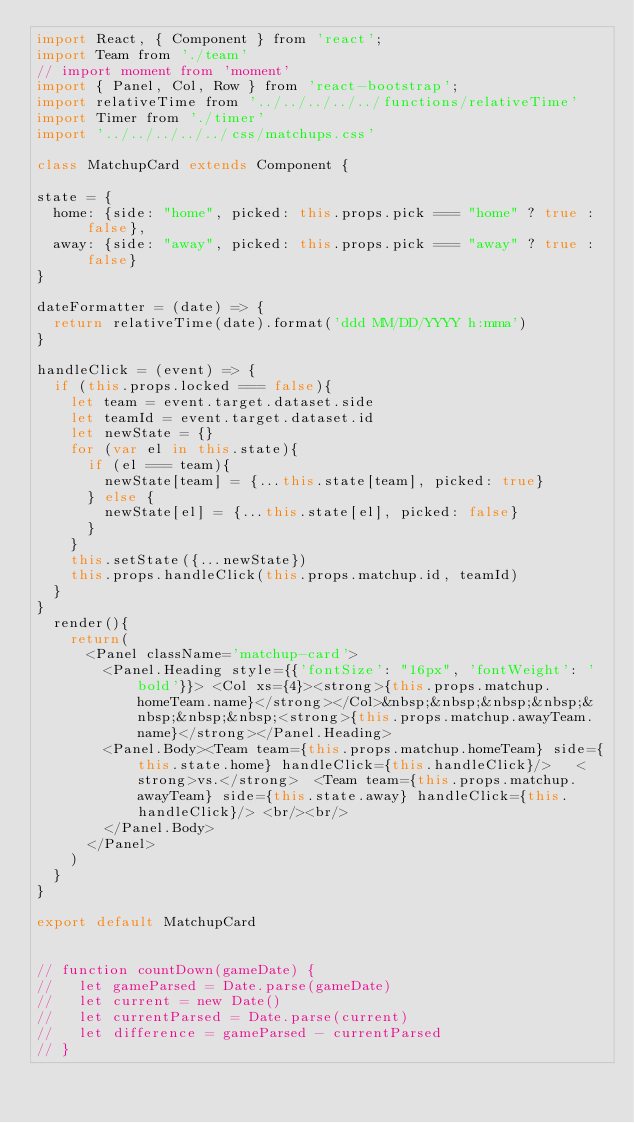<code> <loc_0><loc_0><loc_500><loc_500><_JavaScript_>import React, { Component } from 'react';
import Team from './team'
// import moment from 'moment'
import { Panel, Col, Row } from 'react-bootstrap';
import relativeTime from '../../../../../functions/relativeTime'
import Timer from './timer'
import '../../../../../css/matchups.css'

class MatchupCard extends Component {

state = {
  home: {side: "home", picked: this.props.pick === "home" ? true : false},
  away: {side: "away", picked: this.props.pick === "away" ? true : false}
}

dateFormatter = (date) => {
  return relativeTime(date).format('ddd MM/DD/YYYY h:mma')
}

handleClick = (event) => {
  if (this.props.locked === false){
    let team = event.target.dataset.side
    let teamId = event.target.dataset.id
    let newState = {}
    for (var el in this.state){
      if (el === team){
        newState[team] = {...this.state[team], picked: true}
      } else {
        newState[el] = {...this.state[el], picked: false}
      }
    }
    this.setState({...newState})
    this.props.handleClick(this.props.matchup.id, teamId)
  }
}
  render(){
    return(
      <Panel className='matchup-card'>
        <Panel.Heading style={{'fontSize': "16px", 'fontWeight': 'bold'}}> <Col xs={4}><strong>{this.props.matchup.homeTeam.name}</strong></Col>&nbsp;&nbsp;&nbsp;&nbsp;&nbsp;&nbsp;&nbsp;<strong>{this.props.matchup.awayTeam.name}</strong></Panel.Heading>
        <Panel.Body><Team team={this.props.matchup.homeTeam} side={this.state.home} handleClick={this.handleClick}/>   <strong>vs.</strong>  <Team team={this.props.matchup.awayTeam} side={this.state.away} handleClick={this.handleClick}/> <br/><br/>
        </Panel.Body>
      </Panel>
    )
  }
}

export default MatchupCard


// function countDown(gameDate) {
//   let gameParsed = Date.parse(gameDate)
//   let current = new Date()
//   let currentParsed = Date.parse(current)
//   let difference = gameParsed - currentParsed
// }
</code> 